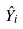<formula> <loc_0><loc_0><loc_500><loc_500>\hat { Y } _ { i }</formula> 